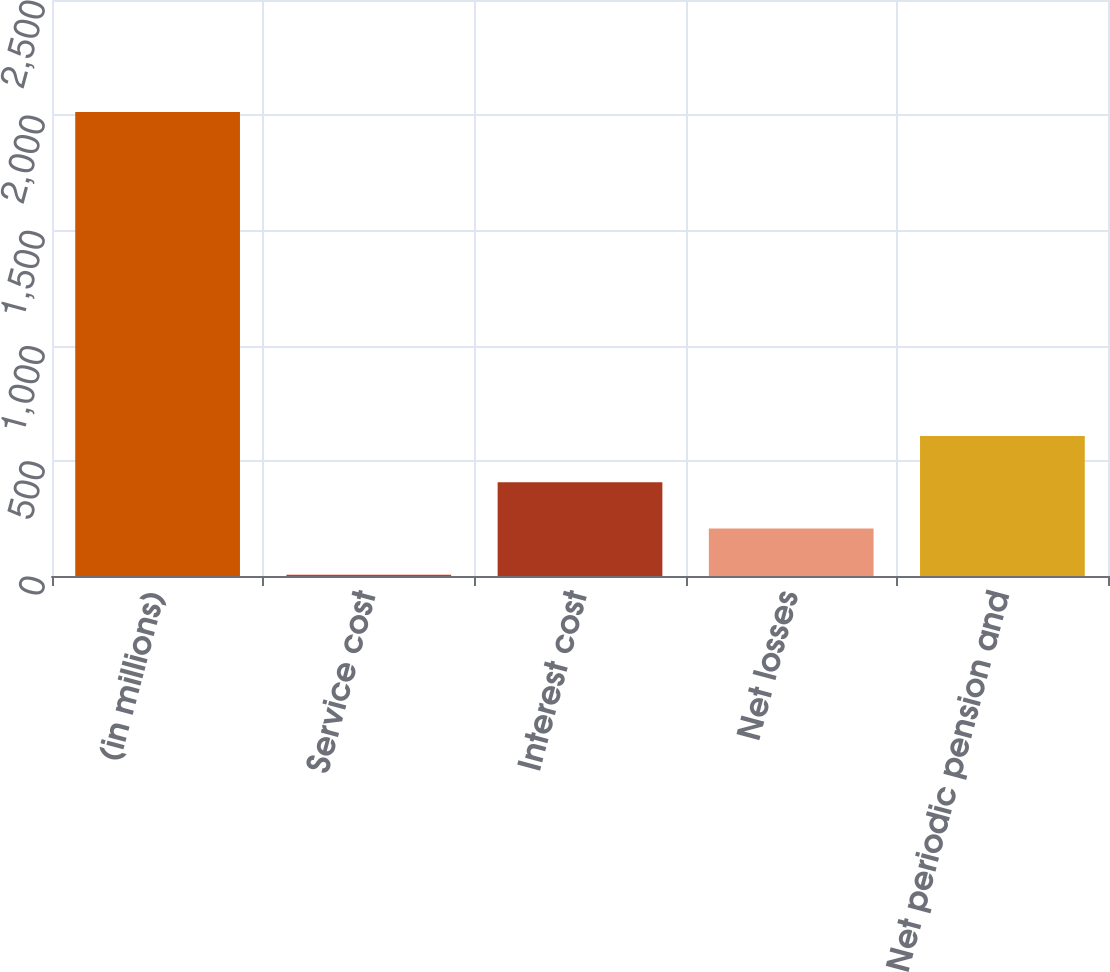Convert chart to OTSL. <chart><loc_0><loc_0><loc_500><loc_500><bar_chart><fcel>(in millions)<fcel>Service cost<fcel>Interest cost<fcel>Net losses<fcel>Net periodic pension and<nl><fcel>2014<fcel>5<fcel>406.8<fcel>205.9<fcel>607.7<nl></chart> 